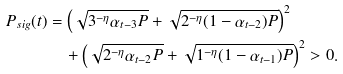Convert formula to latex. <formula><loc_0><loc_0><loc_500><loc_500>P _ { s i g } ( t ) & = \left ( \sqrt { 3 ^ { - \eta } \alpha _ { t - 3 } P } + \sqrt { 2 ^ { - \eta } ( 1 - \alpha _ { t - 2 } ) P } \right ) ^ { 2 } \\ & \quad + \left ( \sqrt { 2 ^ { - \eta } \alpha _ { t - 2 } P } + \sqrt { 1 ^ { - \eta } ( 1 - \alpha _ { t - 1 } ) P } \right ) ^ { 2 } > 0 .</formula> 